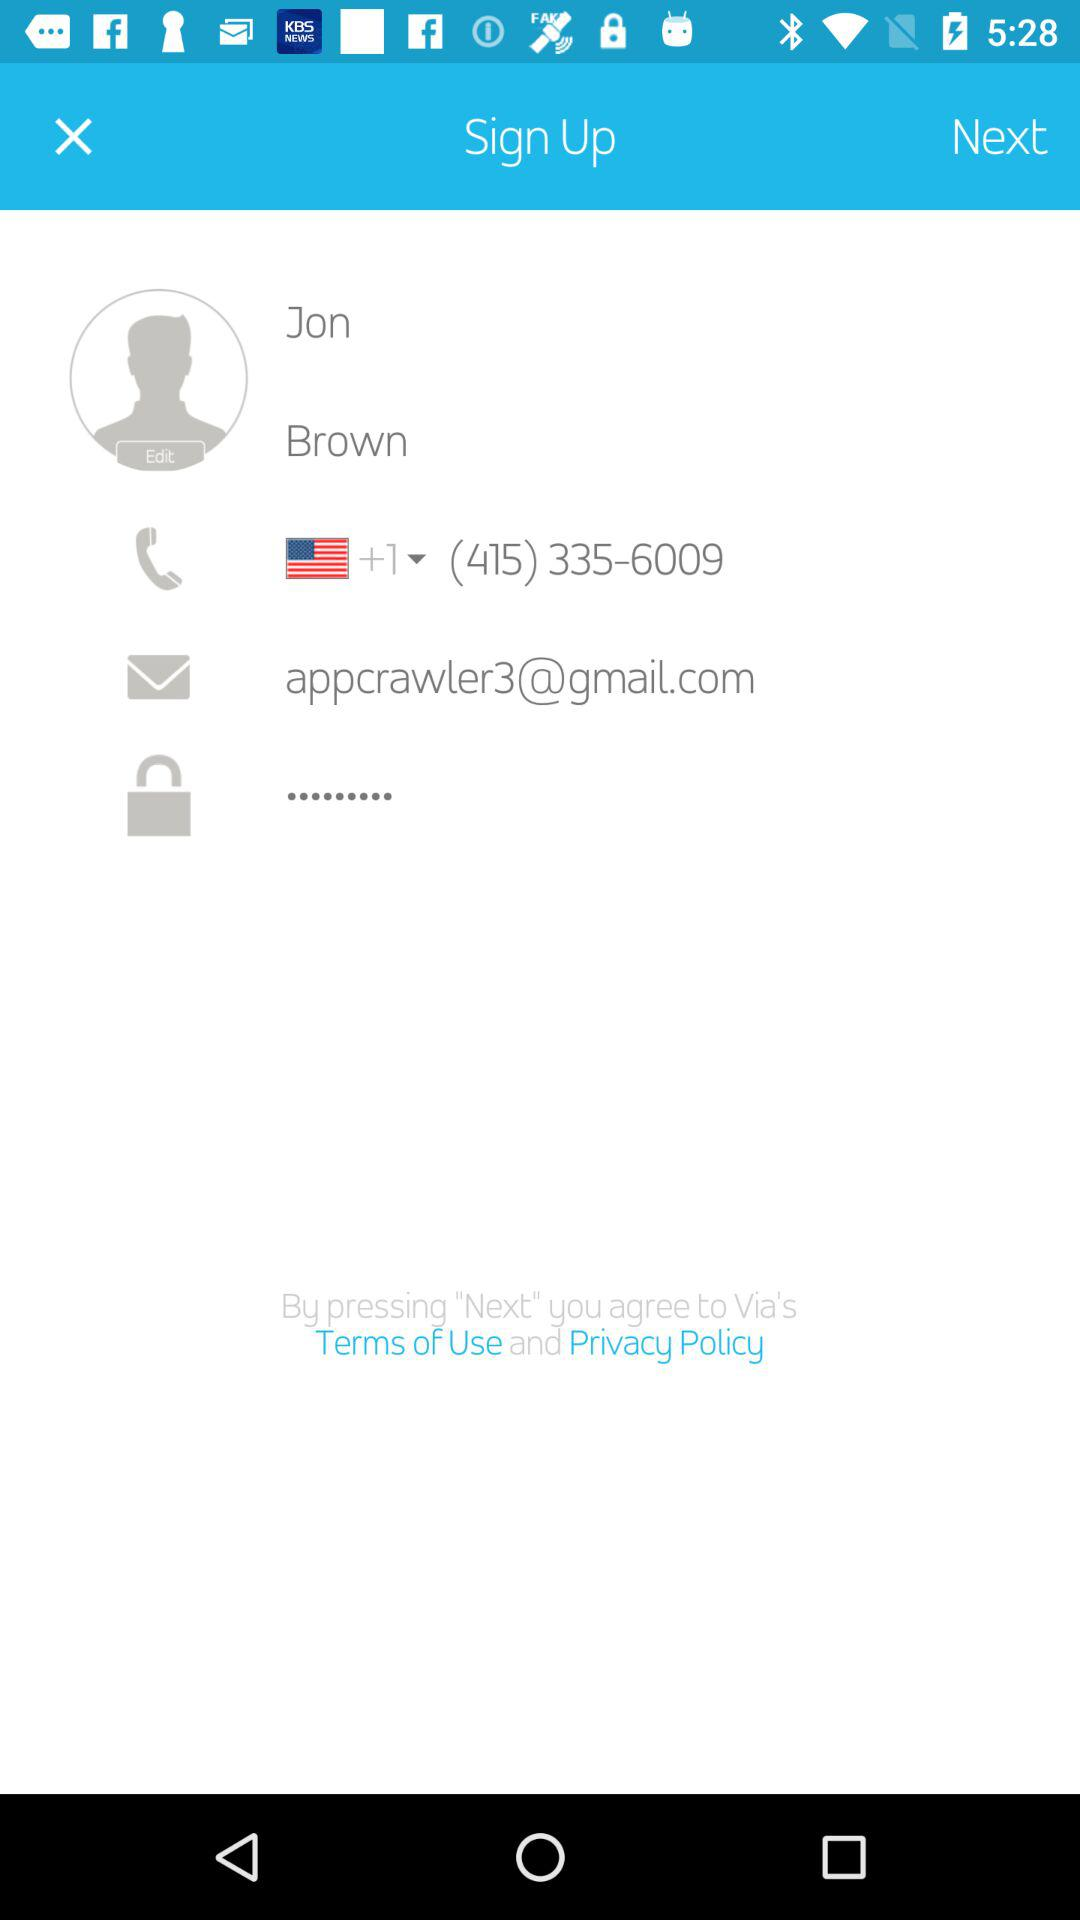What phone number is shown on the screen? The phone number shown on the screen is (415) 335-6009. 